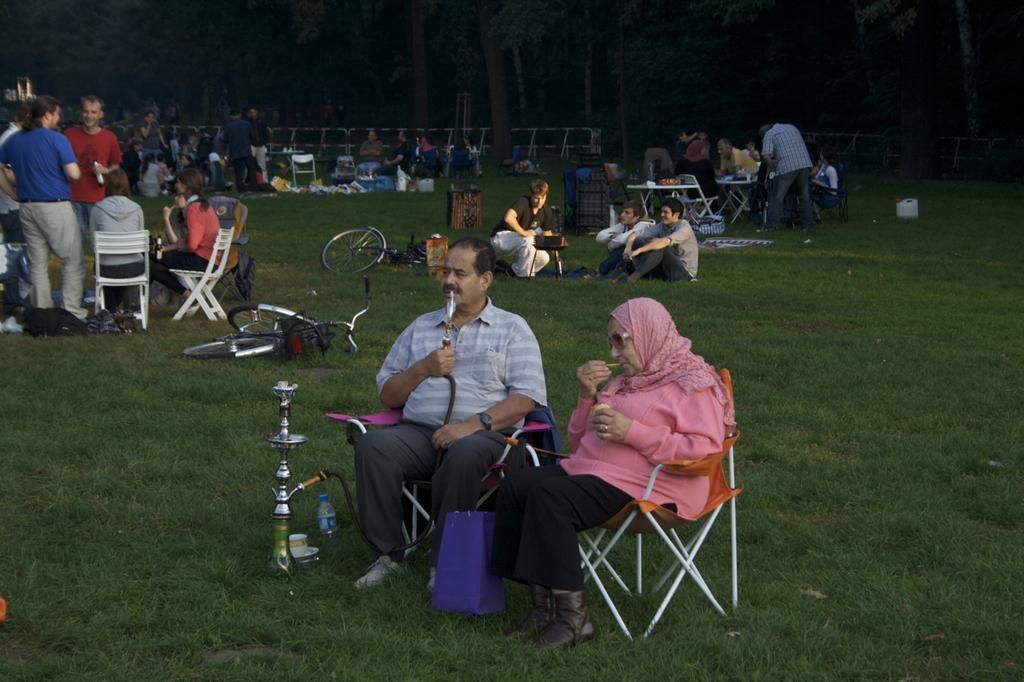In one or two sentences, can you explain what this image depicts? There are two persons sitting in chair and there is a hookah pot in front of them and there are group of people and trees in the background and the ground is greenery. 